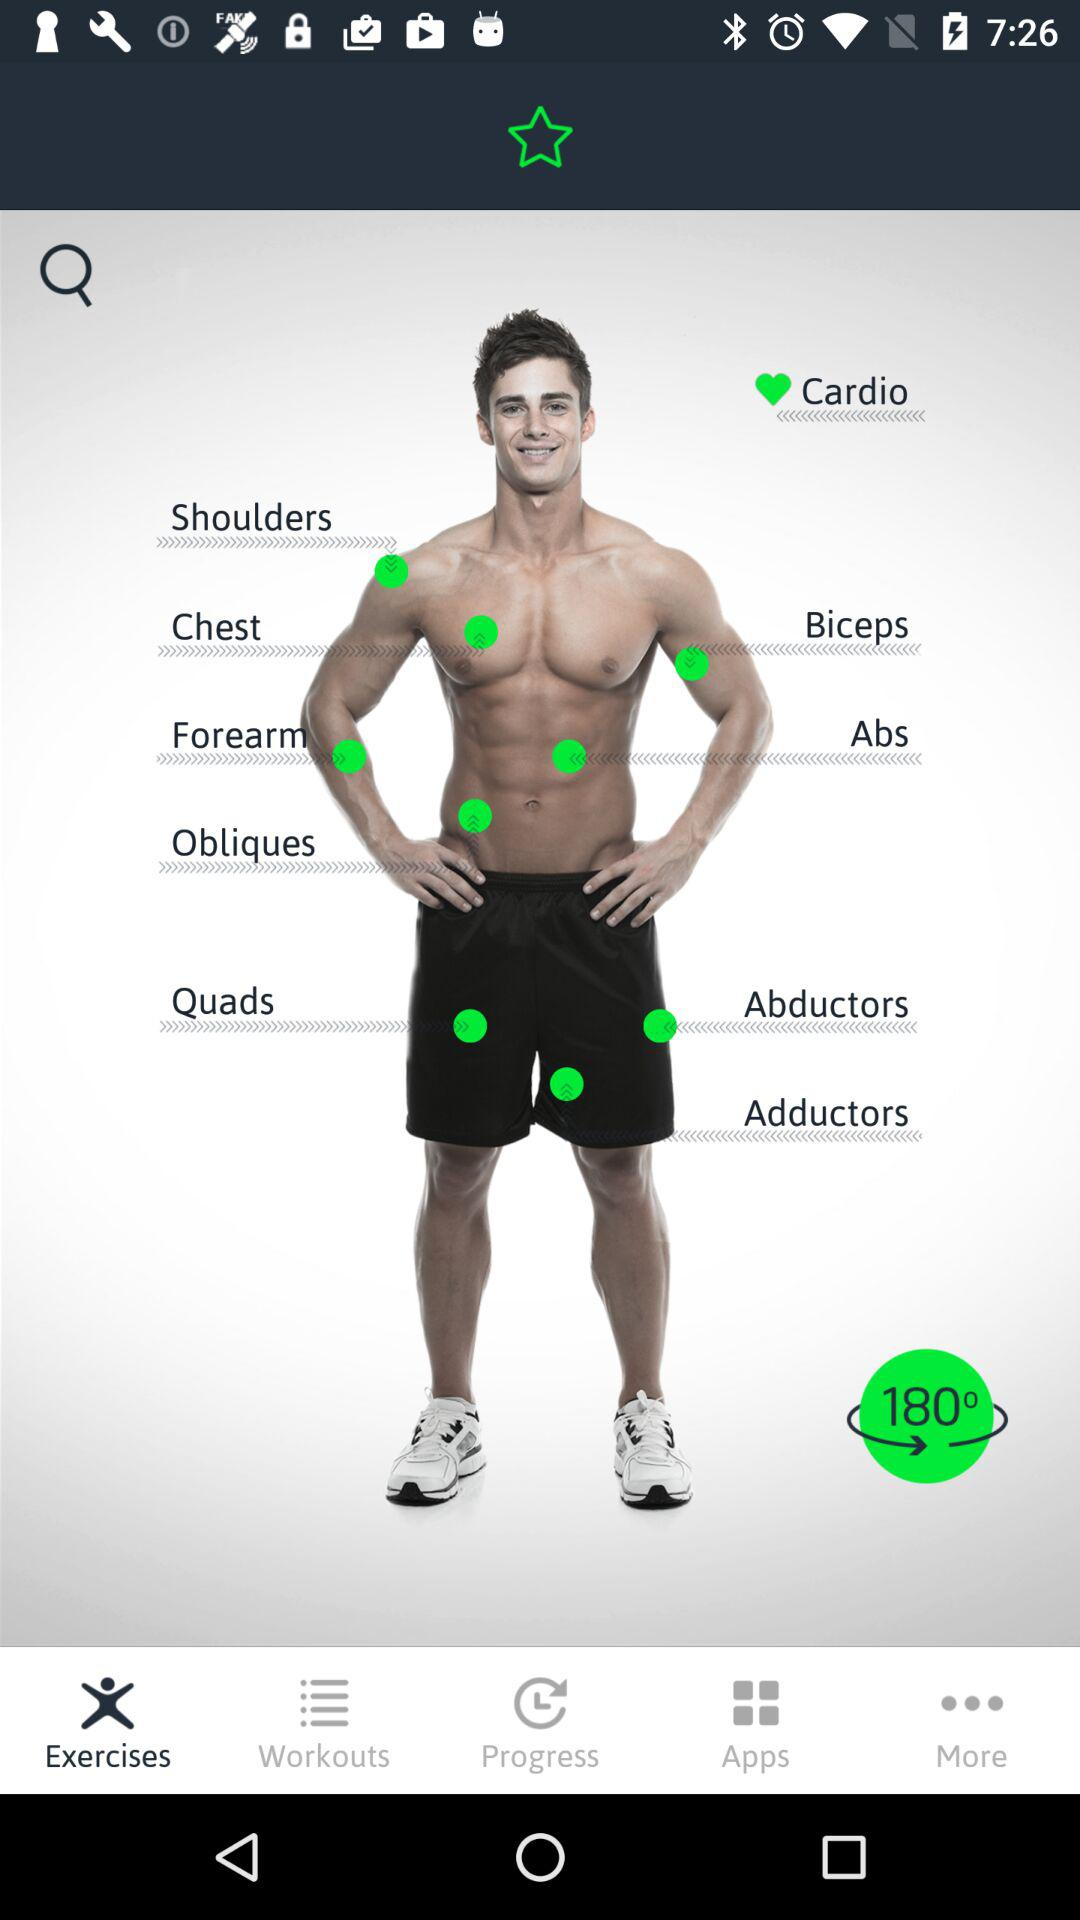Which types of body exercises are available? The available types of body exercises are "Cardio", "Shoulders", "Chest", "Forearm", "Biceps", "Abs", "Obliques", "Quads", "Abductors" and "Adductors". 